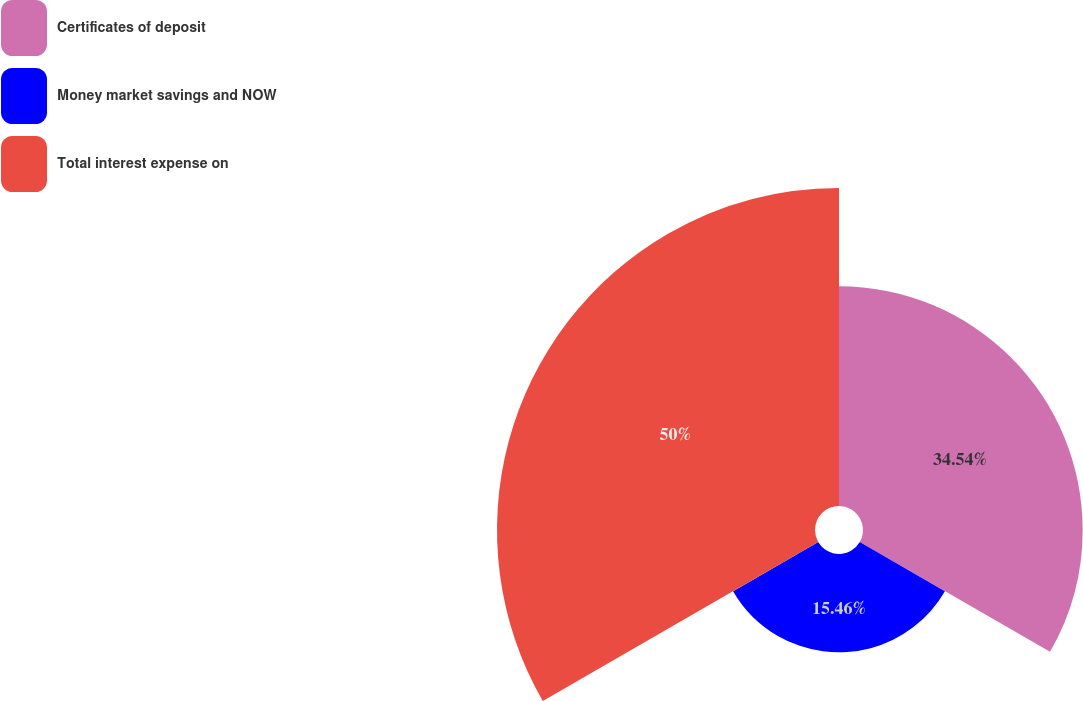<chart> <loc_0><loc_0><loc_500><loc_500><pie_chart><fcel>Certificates of deposit<fcel>Money market savings and NOW<fcel>Total interest expense on<nl><fcel>34.54%<fcel>15.46%<fcel>50.0%<nl></chart> 